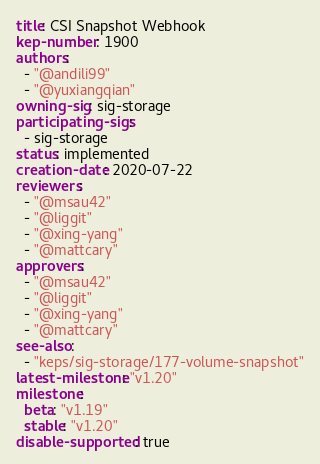Convert code to text. <code><loc_0><loc_0><loc_500><loc_500><_YAML_>title: CSI Snapshot Webhook
kep-number: 1900
authors:
  - "@andili99"
  - "@yuxiangqian"
owning-sig: sig-storage
participating-sigs:
  - sig-storage
status: implemented
creation-date: 2020-07-22
reviewers:
  - "@msau42"
  - "@liggit"
  - "@xing-yang"
  - "@mattcary"
approvers:
  - "@msau42"
  - "@liggit"
  - "@xing-yang"
  - "@mattcary"
see-also:
  - "keps/sig-storage/177-volume-snapshot"
latest-milestone: "v1.20"
milestone:
  beta: "v1.19"
  stable: "v1.20"
disable-supported: true
</code> 